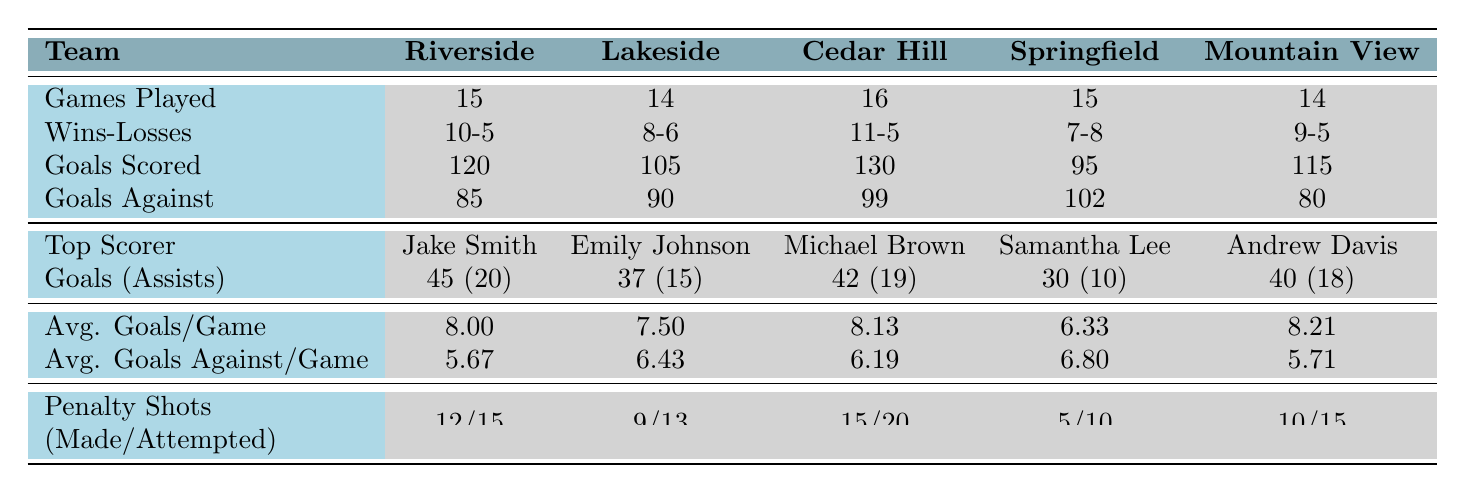What is the total number of games played by all teams combined? To find the total number of games played, we sum the games played by each team: 15 (Riverside) + 14 (Lakeside) + 16 (Cedar Hill) + 15 (Springfield) + 14 (Mountain View) = 74.
Answer: 74 Which team has the highest goals scored in the season? By comparing the 'Goals Scored' column, Riverside scored 120, Cedar Hill scored 130, which is the highest compared to the other teams.
Answer: Cedar Hill High What is the average number of goals scored per game for Lakeside Academy? The average goals per game for Lakeside Academy is listed directly in the table as 7.5.
Answer: 7.5 Did Springfield High School win more games than they lost? Springfield High has 7 wins and 8 losses. Since 7 is less than 8, they did not win more games than they lost.
Answer: No Which team had the best goal differential (goals scored - goals against)? The goal differential for each team is calculated as follows: Riverside (120 - 85 = 35), Lakeside (105 - 90 = 15), Cedar Hill (130 - 99 = 31), Springfield (95 - 102 = -7), Mountain View (115 - 80 = 35). Riverside and Mountain View both have the best differential at 35, but the first one mentioned is Riverside.
Answer: Riverside High School What is the average number of penalty shots made across all teams? To find the average number of penalty shots made, we sum the shots made: 12 (Riverside) + 9 (Lakeside) + 15 (Cedar Hill) + 5 (Springfield) + 10 (Mountain View) = 51. Then divide by the number of teams (5): 51/5 = 10.2.
Answer: 10.2 How many goals did the top scorer of Mountain View High School achieve? The top scorer for Mountain View is Andrew Davis, who scored 40 goals as specified in the table.
Answer: 40 Which player had the most assists in the season and how many did they have? By checking the assists of each top scorer, Jake Smith has 20, Emily Johnson has 15, Michael Brown has 19, Samantha Lee has 10, and Andrew Davis has 18. Since 20 is the highest, Jake Smith had the most assists.
Answer: Jake Smith, 20 assists Is Lakeside Academy's average goals against per game higher than Riverside High School's? Lakeside Academy's average goals against per game is 6.43, while Riverside's is 5.67. Since 6.43 is greater than 5.67, Lakeside's average is higher.
Answer: Yes If you combine the total number of wins from Cedar Hill and Riverside, what do you get? Cedar Hill has 11 wins and Riverside has 10 wins. When combined: 11 + 10 = 21.
Answer: 21 